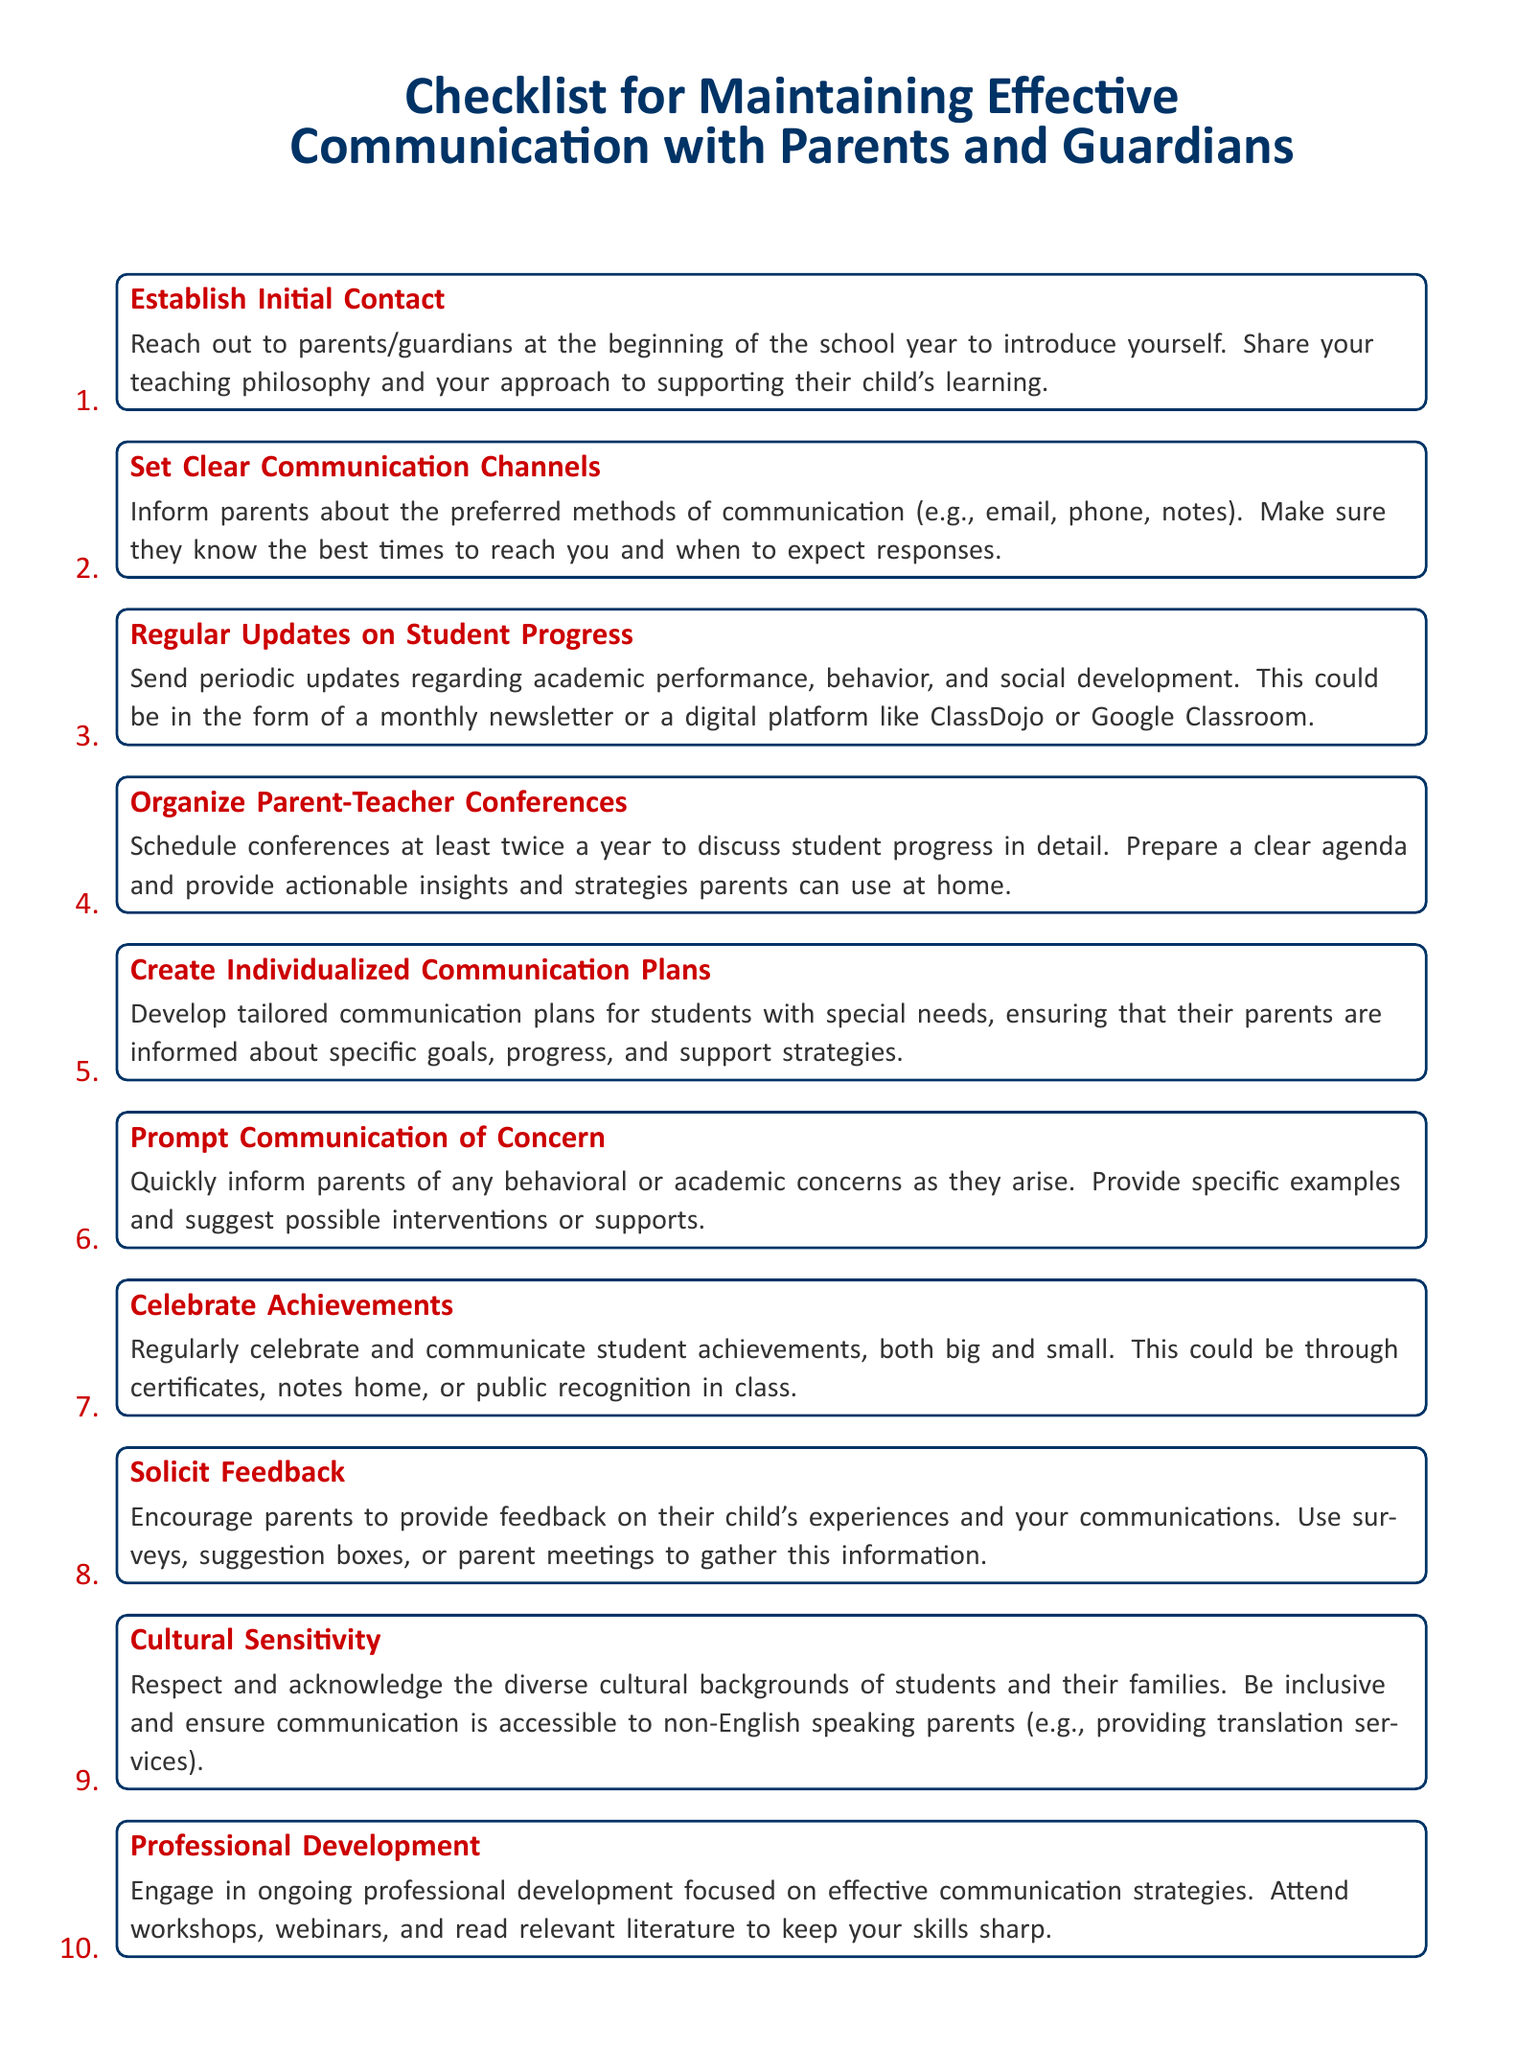what is the first item on the checklist? The first item on the checklist is the initial contact with parents/guardians.
Answer: Establish Initial Contact how many times a year should parent-teacher conferences be organized? The document states that parent-teacher conferences should be scheduled at least twice a year.
Answer: twice what is one way to celebrate student achievements? The document suggests public recognition in class as a way to celebrate achievements.
Answer: public recognition in class which item focuses on communication plans for students with special needs? The document mentions creating individualized communication plans specifically for students with special needs.
Answer: Create Individualized Communication Plans what should be included in the regular updates on student progress? The updates should include academic performance, behavior, and social development.
Answer: academic performance, behavior, and social development which item addresses the need for cultural awareness in communication? The checklist includes an item on cultural sensitivity towards diverse backgrounds.
Answer: Cultural Sensitivity how can parents provide feedback according to the checklist? Parents can provide feedback using surveys, suggestion boxes, or parent meetings.
Answer: surveys, suggestion boxes, or parent meetings what type of professional development is recommended? The document recommends engaging in ongoing professional development focused on effective communication strategies.
Answer: ongoing professional development 